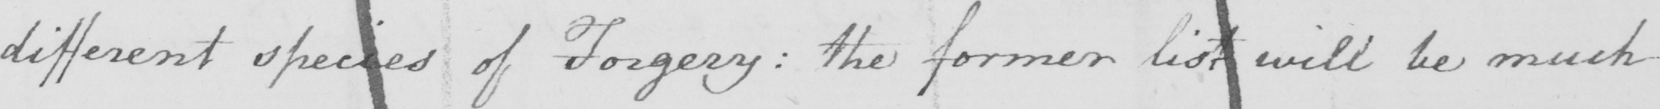Transcribe the text shown in this historical manuscript line. different species of Forgery :  the former list will be much 